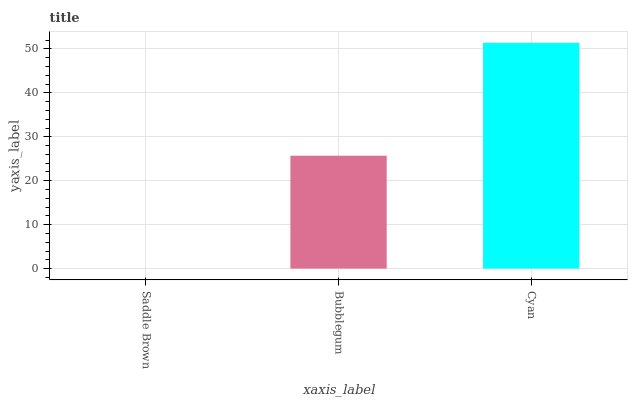Is Saddle Brown the minimum?
Answer yes or no. Yes. Is Cyan the maximum?
Answer yes or no. Yes. Is Bubblegum the minimum?
Answer yes or no. No. Is Bubblegum the maximum?
Answer yes or no. No. Is Bubblegum greater than Saddle Brown?
Answer yes or no. Yes. Is Saddle Brown less than Bubblegum?
Answer yes or no. Yes. Is Saddle Brown greater than Bubblegum?
Answer yes or no. No. Is Bubblegum less than Saddle Brown?
Answer yes or no. No. Is Bubblegum the high median?
Answer yes or no. Yes. Is Bubblegum the low median?
Answer yes or no. Yes. Is Cyan the high median?
Answer yes or no. No. Is Saddle Brown the low median?
Answer yes or no. No. 